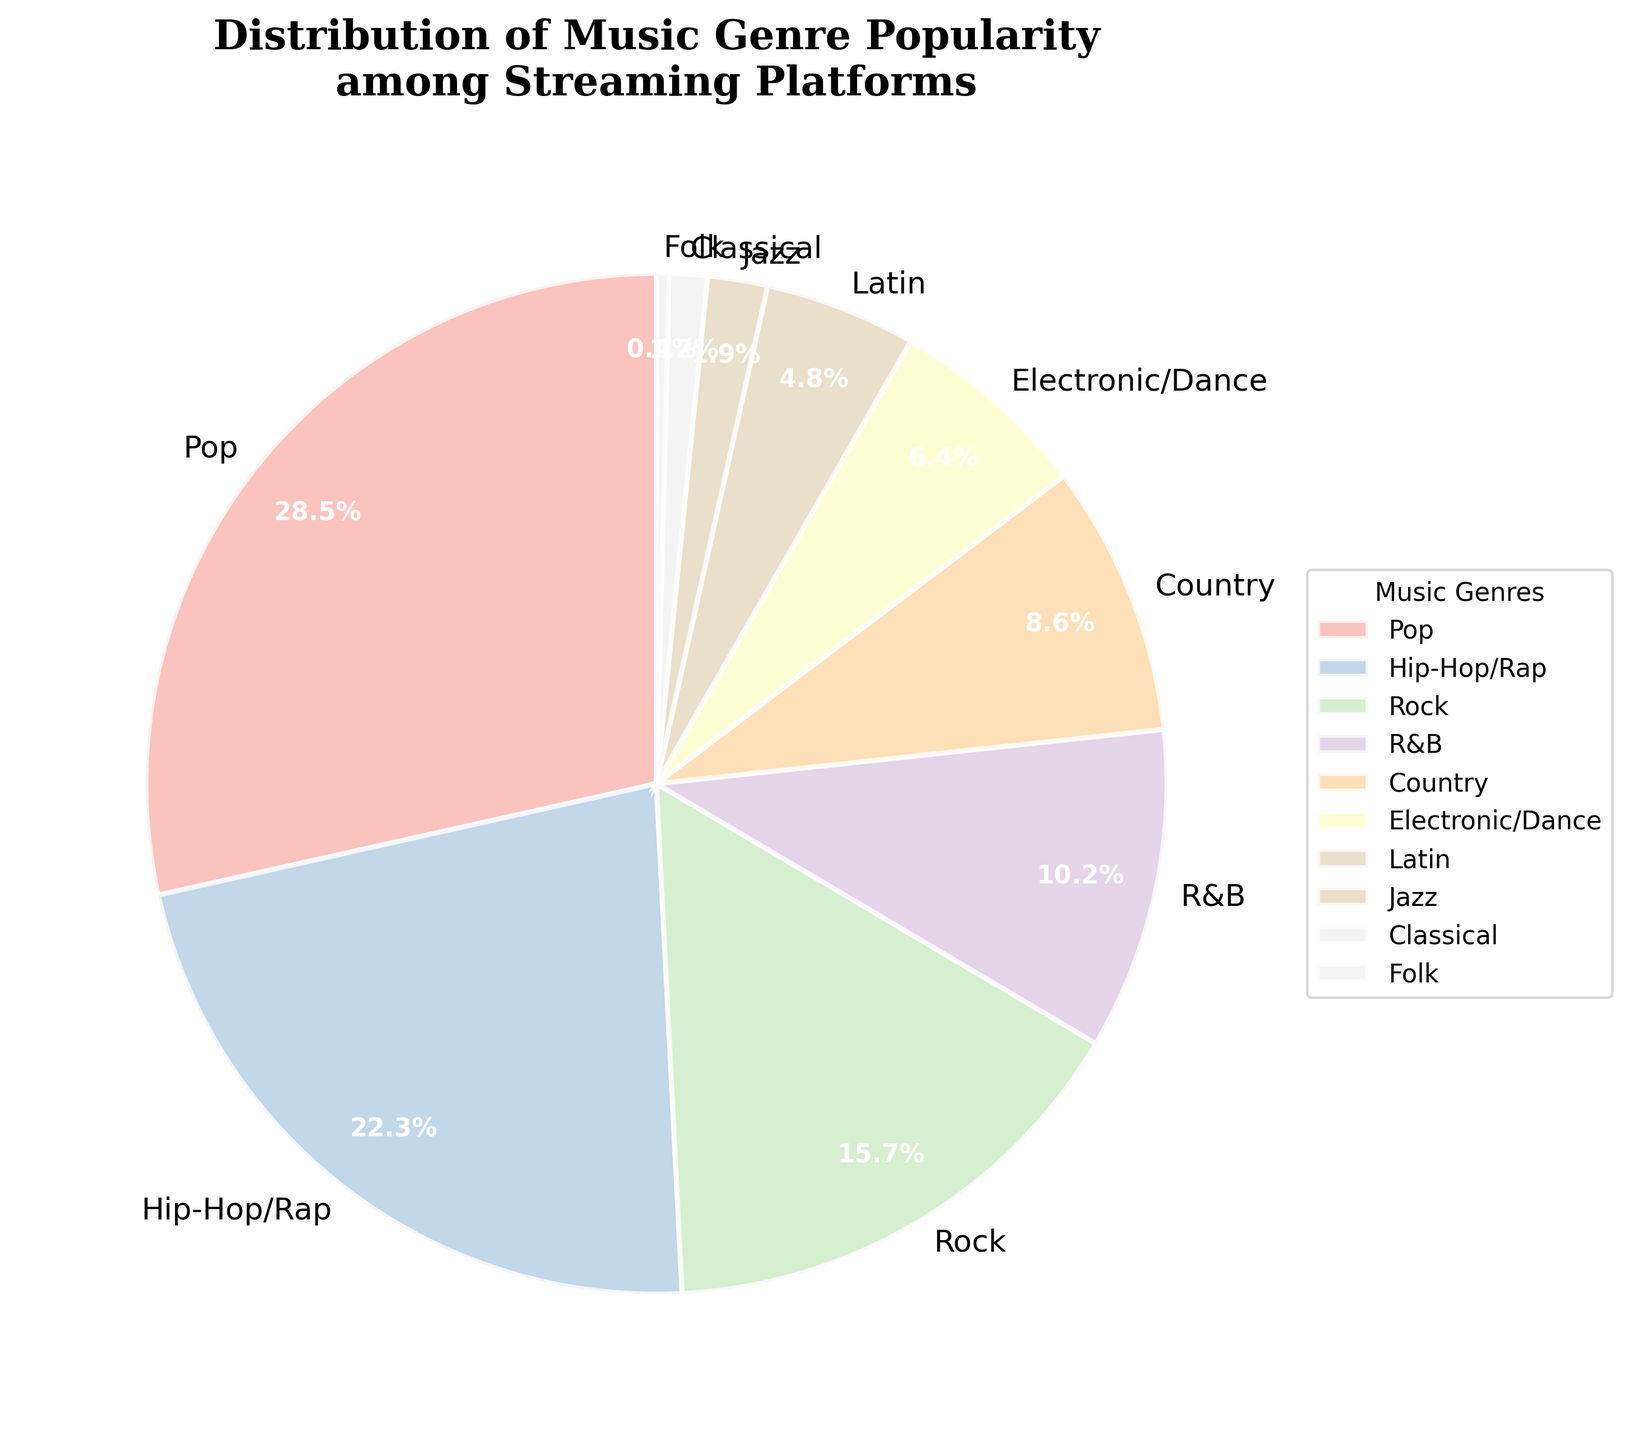What percentage of the total is represented by Pop and Hip-Hop/Rap combined? To find the combined percentage, add the individual percentages of Pop and Hip-Hop/Rap: 28.5% (Pop) + 22.3% (Hip-Hop/Rap) = 50.8%.
Answer: 50.8% Which genre has the smallest percentage representation? The genre with the smallest percentage representation is identified by locating the smallest value in the pie chart. Folk has a percentage of 0.4%, which is the smallest.
Answer: Folk Is the percentage of Rock more than twice that of Country? The percentage of Rock is 15.7%. To check if it is more than twice that of Country, calculate twice the percentage of Country: 2 * 8.6% = 17.2%. Since 15.7% (Rock) is less than 17.2%, Rock is not more than twice that of Country.
Answer: No What is the difference between the percentages of R&B and Jazz? Subtract the percentage of Jazz from the percentage of R&B to find the difference: 10.2% (R&B) - 1.9% (Jazz) = 8.3%.
Answer: 8.3% Which genre falls just below Pop in terms of percentage? To determine which genre falls just below Pop, look at the next largest percentage after Pop, which is 22.3% for Hip-Hop/Rap.
Answer: Hip-Hop/Rap Are the combined percentages of Electronic/Dance and Latin more than that of Rock? Add the percentages of Electronic/Dance and Latin: 6.4% + 4.8% = 11.2%. Compare this to the percentage of Rock which is 15.7%. 11.2% is less than 15.7%.
Answer: No How many genres have a percentage representation less than 5%? The genres with percentages less than 5% are Latin (4.8%), Jazz (1.9%), Classical (1.2%), and Folk (0.4%). There are 4 such genres.
Answer: 4 What percentage more is Pop compared to Classical? Subtract the percentage of Classical from Pop to find the additional percentage: 28.5% (Pop) - 1.2% (Classical) = 27.3%.
Answer: 27.3% Which genre is immediately represented to the left of Country in the pie chart? To identify this, one needs to look for the genre that appears before Country in a clockwise order starting from the top (90 degrees). R&B is just to the left of Country.
Answer: R&B 